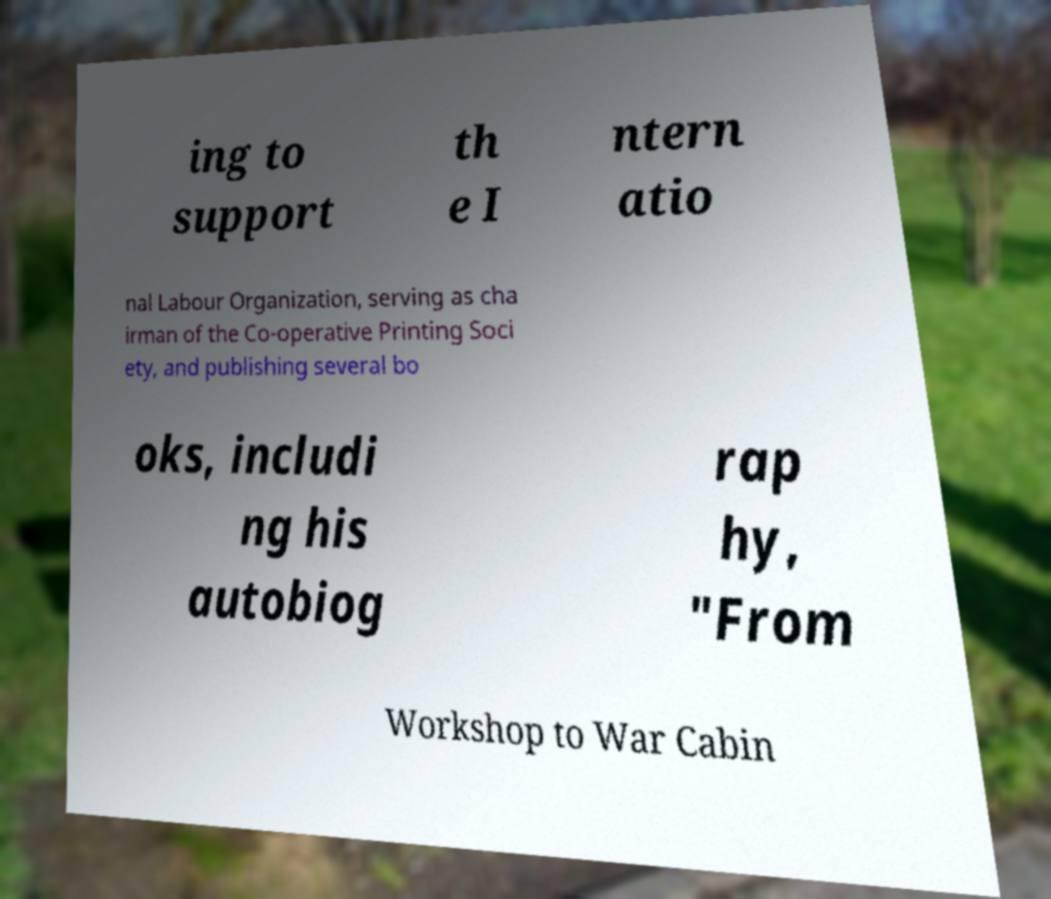What messages or text are displayed in this image? I need them in a readable, typed format. ing to support th e I ntern atio nal Labour Organization, serving as cha irman of the Co-operative Printing Soci ety, and publishing several bo oks, includi ng his autobiog rap hy, "From Workshop to War Cabin 